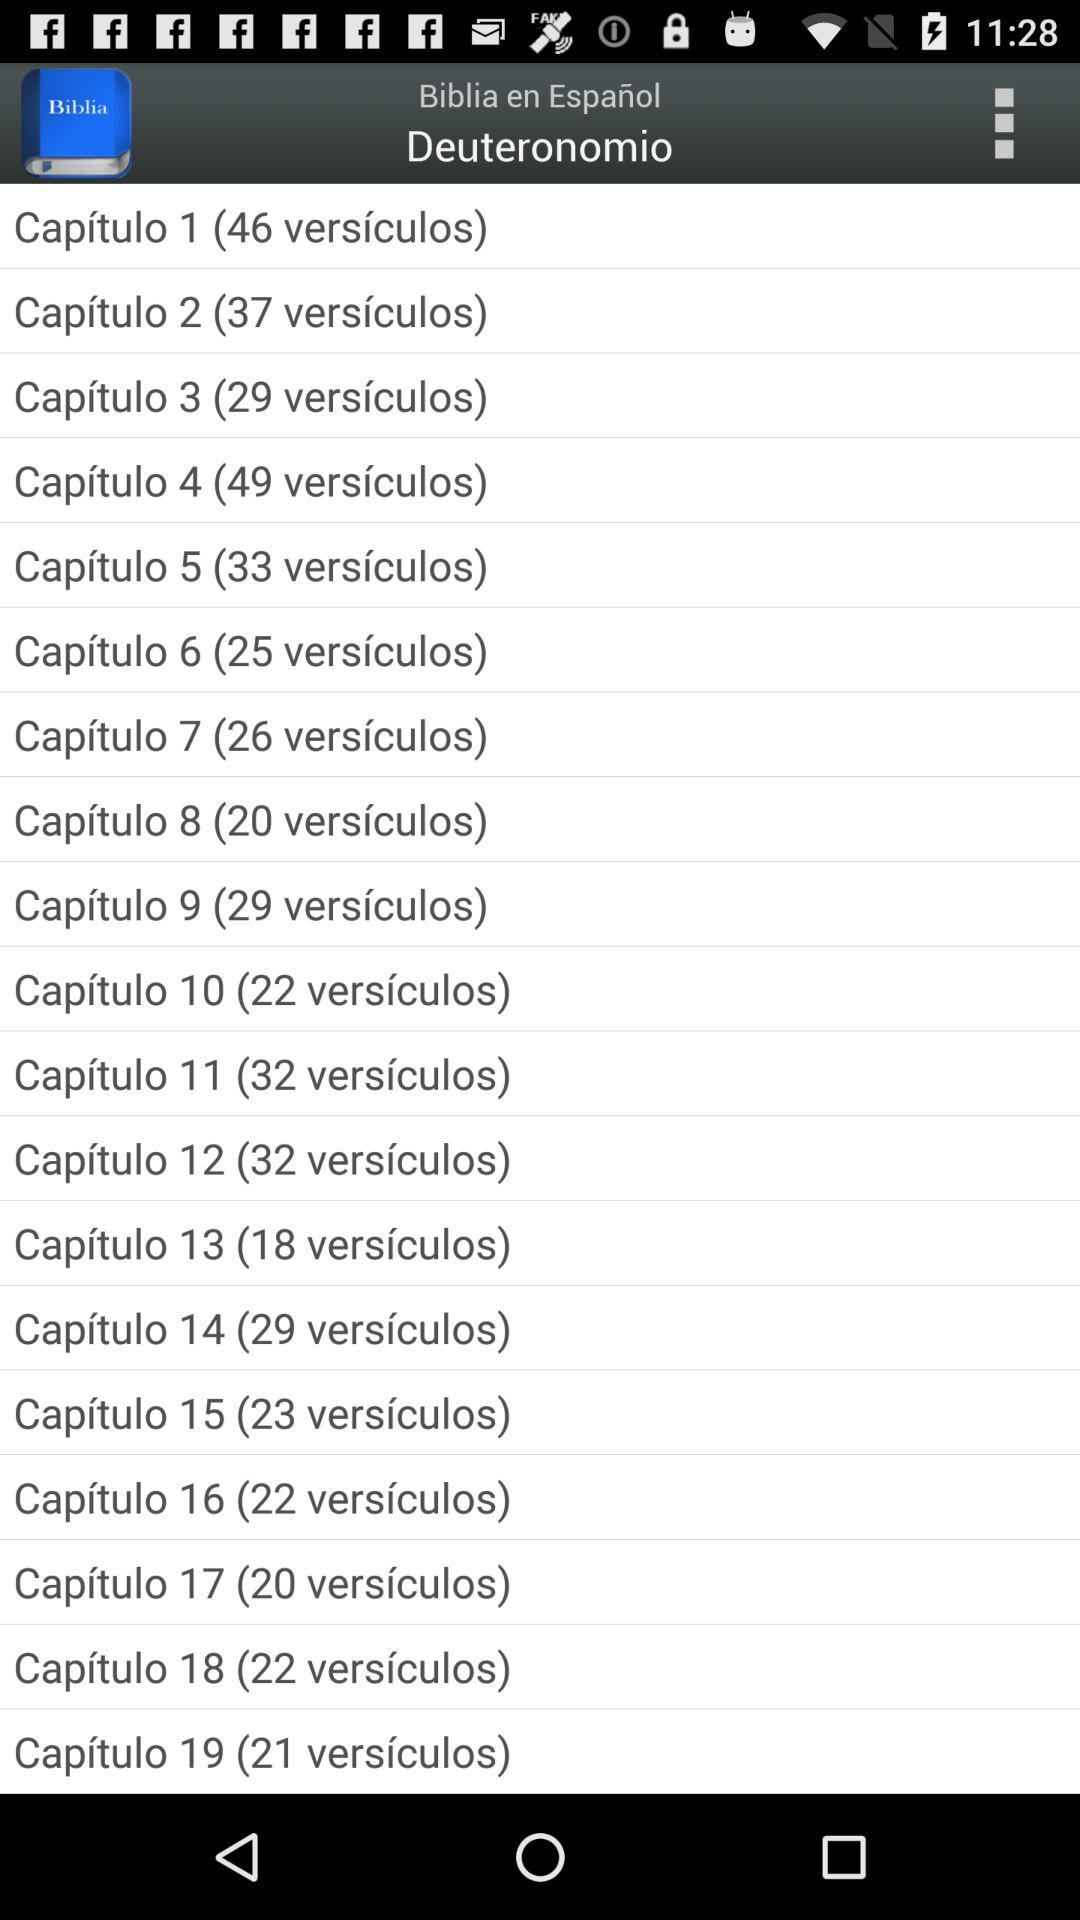How many more verses are in chapter 12 than in chapter 13?
Answer the question using a single word or phrase. 14 